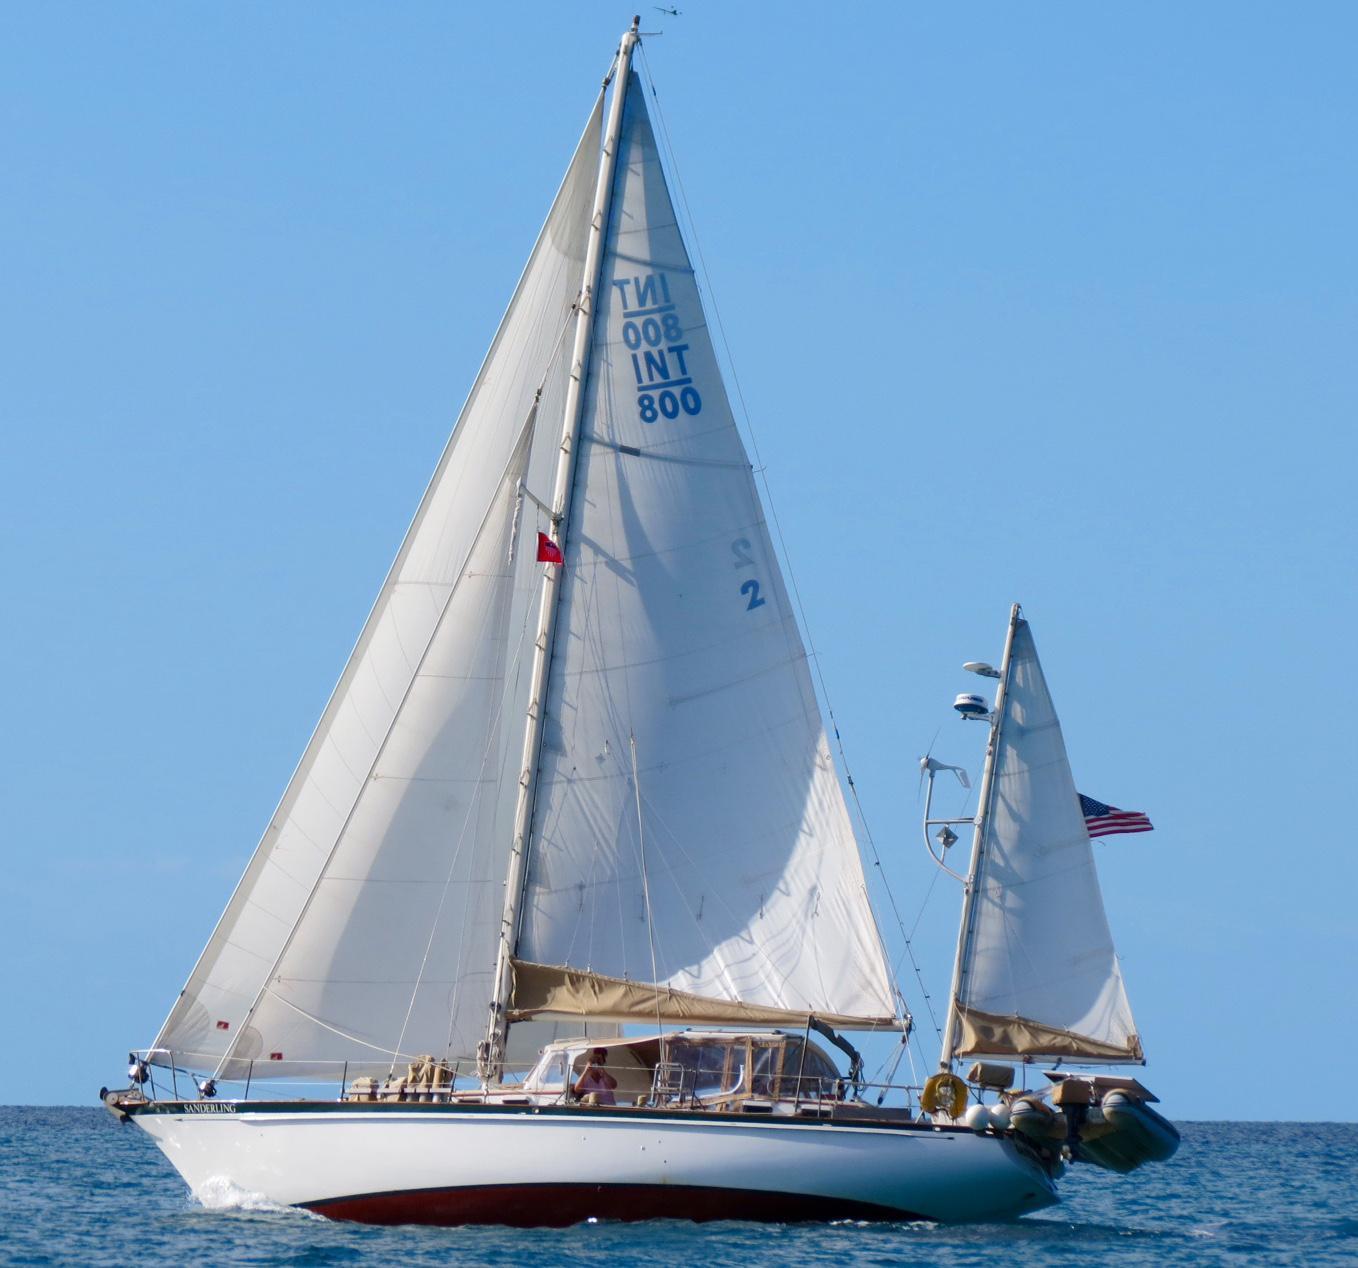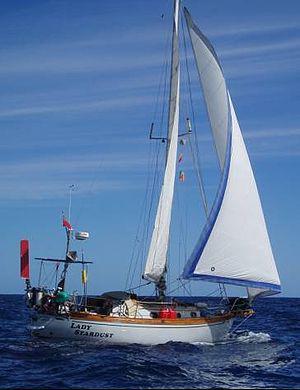The first image is the image on the left, the second image is the image on the right. For the images shown, is this caption "A sailboat moving on deep-blue water has a non-white exterior boat body." true? Answer yes or no. No. The first image is the image on the left, the second image is the image on the right. Analyze the images presented: Is the assertion "A landform sits in the distance behind the boat in the image on the left." valid? Answer yes or no. No. 